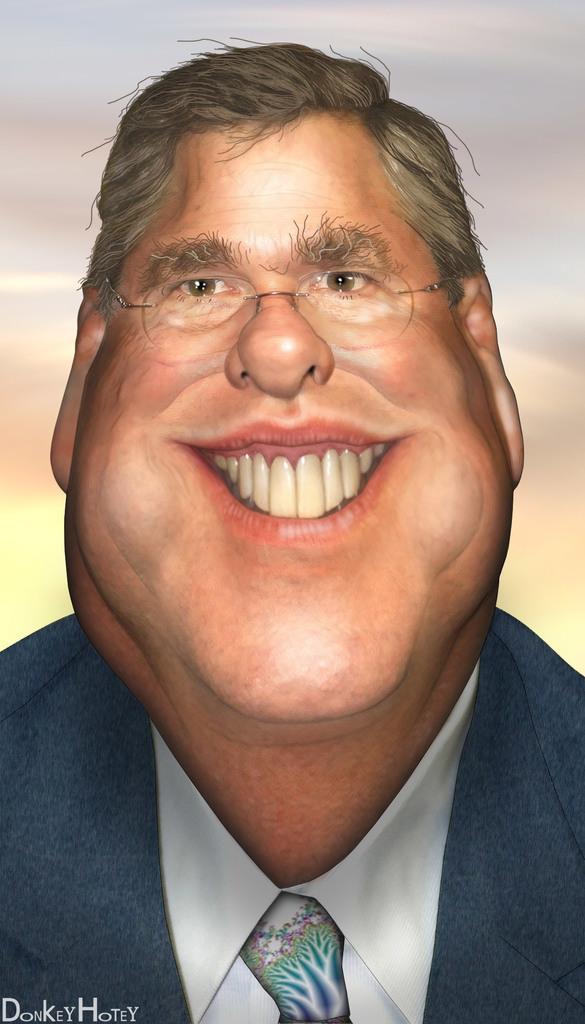Describe this image in one or two sentences. In this image we can see an edited picture of a person wearing a suit. 